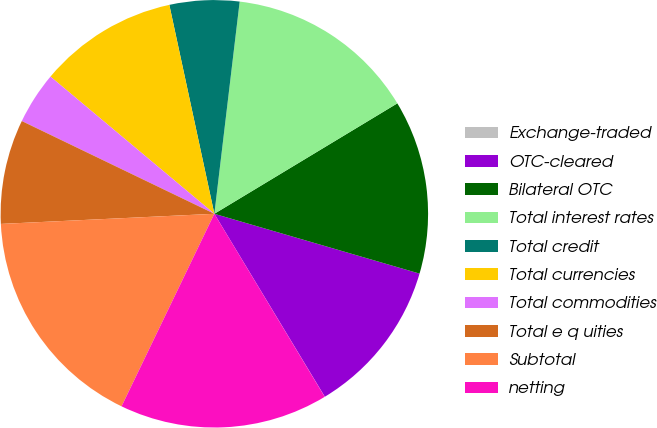Convert chart. <chart><loc_0><loc_0><loc_500><loc_500><pie_chart><fcel>Exchange-traded<fcel>OTC-cleared<fcel>Bilateral OTC<fcel>Total interest rates<fcel>Total credit<fcel>Total currencies<fcel>Total commodities<fcel>Total e q uities<fcel>Subtotal<fcel>netting<nl><fcel>0.01%<fcel>11.84%<fcel>13.16%<fcel>14.47%<fcel>5.27%<fcel>10.53%<fcel>3.95%<fcel>7.9%<fcel>17.1%<fcel>15.79%<nl></chart> 